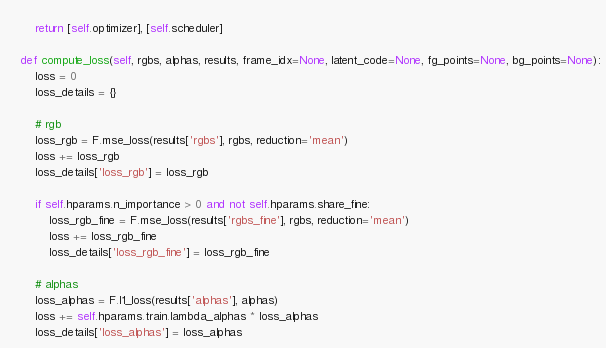Convert code to text. <code><loc_0><loc_0><loc_500><loc_500><_Python_>        
        return [self.optimizer], [self.scheduler]
    
    def compute_loss(self, rgbs, alphas, results, frame_idx=None, latent_code=None, fg_points=None, bg_points=None):
        loss = 0
        loss_details = {}

        # rgb
        loss_rgb = F.mse_loss(results['rgbs'], rgbs, reduction='mean')
        loss += loss_rgb
        loss_details['loss_rgb'] = loss_rgb
        
        if self.hparams.n_importance > 0 and not self.hparams.share_fine:
            loss_rgb_fine = F.mse_loss(results['rgbs_fine'], rgbs, reduction='mean')
            loss += loss_rgb_fine
            loss_details['loss_rgb_fine'] = loss_rgb_fine

        # alphas
        loss_alphas = F.l1_loss(results['alphas'], alphas)
        loss += self.hparams.train.lambda_alphas * loss_alphas
        loss_details['loss_alphas'] = loss_alphas
</code> 